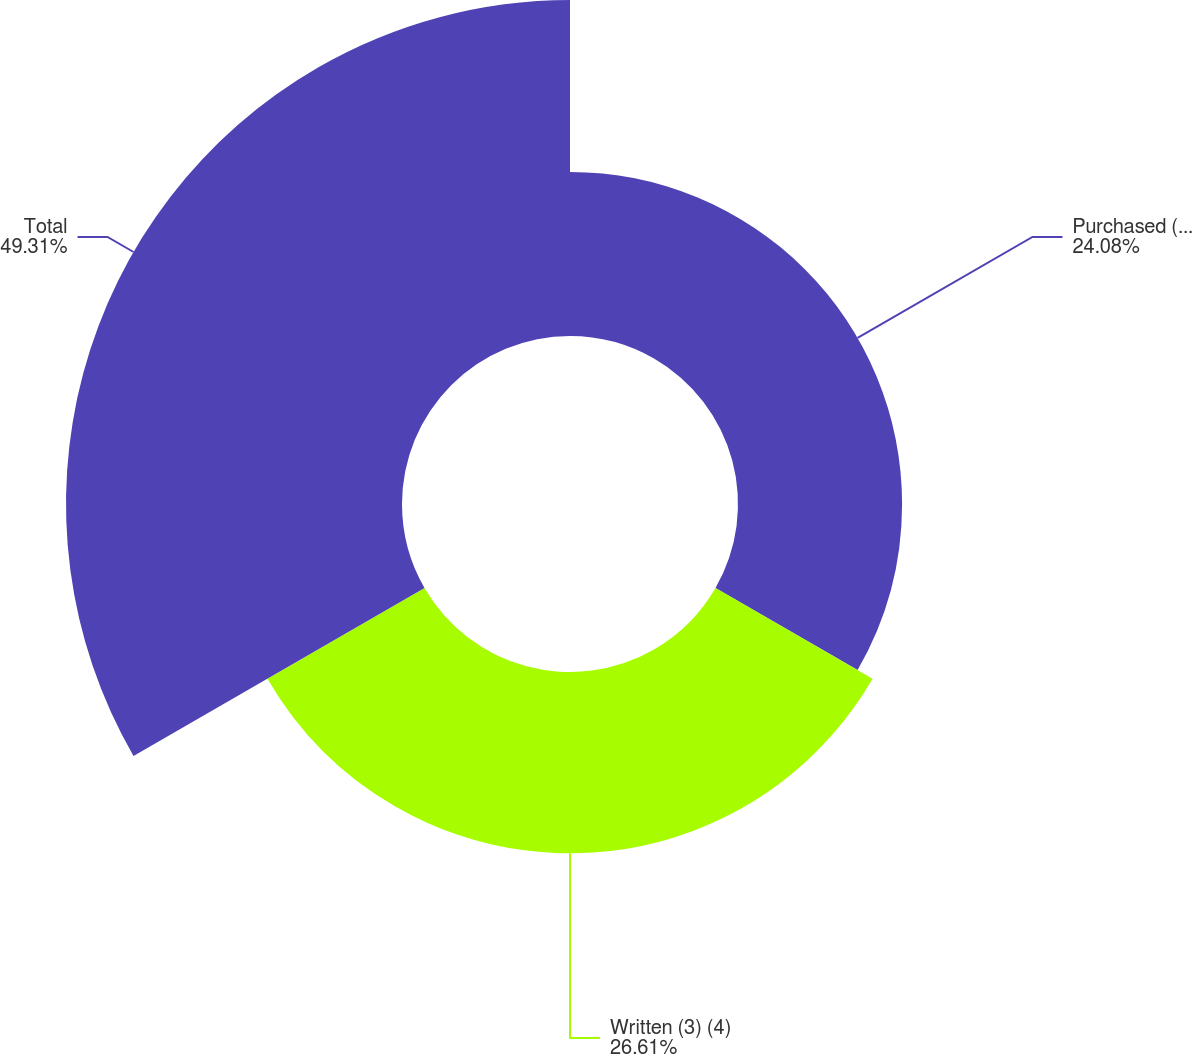<chart> <loc_0><loc_0><loc_500><loc_500><pie_chart><fcel>Purchased (2) (4)<fcel>Written (3) (4)<fcel>Total<nl><fcel>24.08%<fcel>26.61%<fcel>49.31%<nl></chart> 